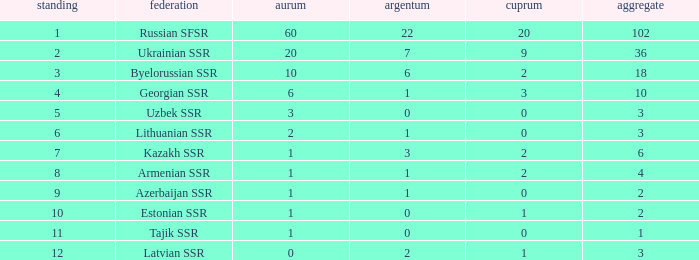What is the sum of bronzes for teams with more than 2 gold, ranked under 3, and less than 22 silver? 9.0. Can you give me this table as a dict? {'header': ['standing', 'federation', 'aurum', 'argentum', 'cuprum', 'aggregate'], 'rows': [['1', 'Russian SFSR', '60', '22', '20', '102'], ['2', 'Ukrainian SSR', '20', '7', '9', '36'], ['3', 'Byelorussian SSR', '10', '6', '2', '18'], ['4', 'Georgian SSR', '6', '1', '3', '10'], ['5', 'Uzbek SSR', '3', '0', '0', '3'], ['6', 'Lithuanian SSR', '2', '1', '0', '3'], ['7', 'Kazakh SSR', '1', '3', '2', '6'], ['8', 'Armenian SSR', '1', '1', '2', '4'], ['9', 'Azerbaijan SSR', '1', '1', '0', '2'], ['10', 'Estonian SSR', '1', '0', '1', '2'], ['11', 'Tajik SSR', '1', '0', '0', '1'], ['12', 'Latvian SSR', '0', '2', '1', '3']]} 